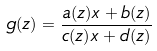Convert formula to latex. <formula><loc_0><loc_0><loc_500><loc_500>g ( z ) = \frac { a ( z ) x + b ( z ) } { c ( z ) x + d ( z ) }</formula> 